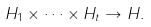<formula> <loc_0><loc_0><loc_500><loc_500>H _ { 1 } \times \cdots \times H _ { t } \to H .</formula> 